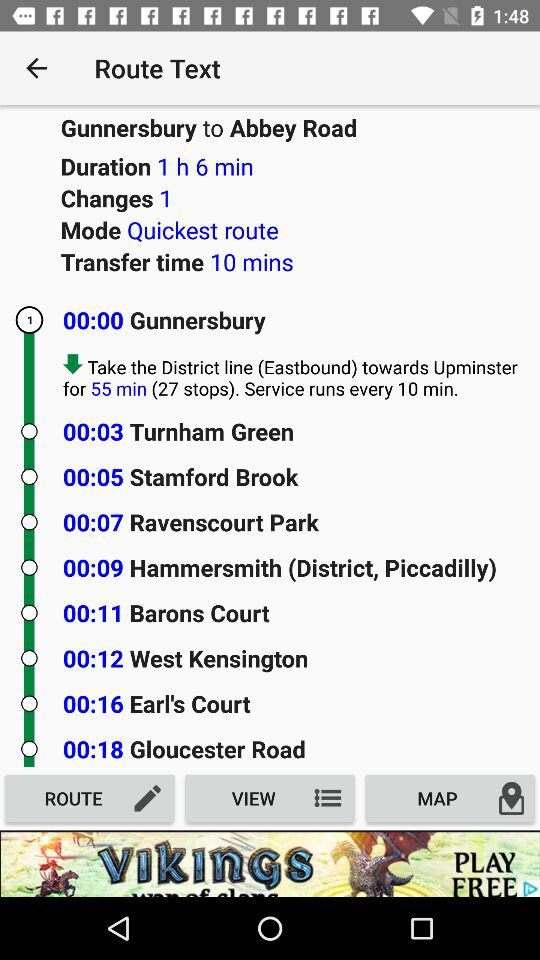How many stops are there in this route?
Answer the question using a single word or phrase. 27 